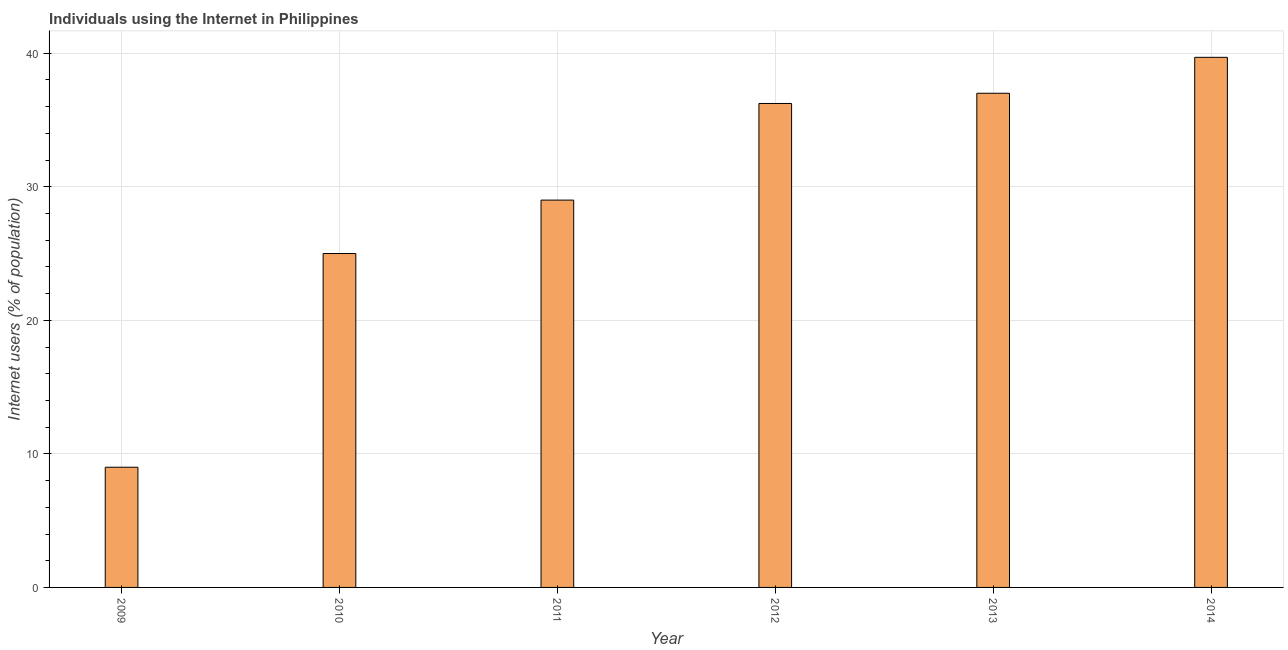Does the graph contain any zero values?
Keep it short and to the point. No. Does the graph contain grids?
Give a very brief answer. Yes. What is the title of the graph?
Provide a succinct answer. Individuals using the Internet in Philippines. What is the label or title of the X-axis?
Provide a succinct answer. Year. What is the label or title of the Y-axis?
Keep it short and to the point. Internet users (% of population). Across all years, what is the maximum number of internet users?
Offer a very short reply. 39.69. Across all years, what is the minimum number of internet users?
Make the answer very short. 9. In which year was the number of internet users maximum?
Your answer should be compact. 2014. In which year was the number of internet users minimum?
Your answer should be compact. 2009. What is the sum of the number of internet users?
Your response must be concise. 175.93. What is the difference between the number of internet users in 2010 and 2011?
Make the answer very short. -4. What is the average number of internet users per year?
Keep it short and to the point. 29.32. What is the median number of internet users?
Your answer should be compact. 32.62. In how many years, is the number of internet users greater than 24 %?
Keep it short and to the point. 5. What is the ratio of the number of internet users in 2011 to that in 2014?
Your answer should be compact. 0.73. What is the difference between the highest and the second highest number of internet users?
Offer a very short reply. 2.69. What is the difference between the highest and the lowest number of internet users?
Your answer should be compact. 30.69. Are all the bars in the graph horizontal?
Make the answer very short. No. Are the values on the major ticks of Y-axis written in scientific E-notation?
Keep it short and to the point. No. What is the Internet users (% of population) in 2009?
Your response must be concise. 9. What is the Internet users (% of population) in 2012?
Your answer should be very brief. 36.24. What is the Internet users (% of population) of 2014?
Offer a very short reply. 39.69. What is the difference between the Internet users (% of population) in 2009 and 2010?
Provide a succinct answer. -16. What is the difference between the Internet users (% of population) in 2009 and 2011?
Provide a succinct answer. -20. What is the difference between the Internet users (% of population) in 2009 and 2012?
Give a very brief answer. -27.24. What is the difference between the Internet users (% of population) in 2009 and 2013?
Keep it short and to the point. -28. What is the difference between the Internet users (% of population) in 2009 and 2014?
Your answer should be compact. -30.69. What is the difference between the Internet users (% of population) in 2010 and 2012?
Your answer should be very brief. -11.24. What is the difference between the Internet users (% of population) in 2010 and 2013?
Your response must be concise. -12. What is the difference between the Internet users (% of population) in 2010 and 2014?
Provide a short and direct response. -14.69. What is the difference between the Internet users (% of population) in 2011 and 2012?
Give a very brief answer. -7.24. What is the difference between the Internet users (% of population) in 2011 and 2013?
Ensure brevity in your answer.  -8. What is the difference between the Internet users (% of population) in 2011 and 2014?
Offer a very short reply. -10.69. What is the difference between the Internet users (% of population) in 2012 and 2013?
Provide a short and direct response. -0.76. What is the difference between the Internet users (% of population) in 2012 and 2014?
Your answer should be very brief. -3.45. What is the difference between the Internet users (% of population) in 2013 and 2014?
Ensure brevity in your answer.  -2.69. What is the ratio of the Internet users (% of population) in 2009 to that in 2010?
Make the answer very short. 0.36. What is the ratio of the Internet users (% of population) in 2009 to that in 2011?
Your response must be concise. 0.31. What is the ratio of the Internet users (% of population) in 2009 to that in 2012?
Ensure brevity in your answer.  0.25. What is the ratio of the Internet users (% of population) in 2009 to that in 2013?
Your response must be concise. 0.24. What is the ratio of the Internet users (% of population) in 2009 to that in 2014?
Keep it short and to the point. 0.23. What is the ratio of the Internet users (% of population) in 2010 to that in 2011?
Provide a short and direct response. 0.86. What is the ratio of the Internet users (% of population) in 2010 to that in 2012?
Keep it short and to the point. 0.69. What is the ratio of the Internet users (% of population) in 2010 to that in 2013?
Your answer should be very brief. 0.68. What is the ratio of the Internet users (% of population) in 2010 to that in 2014?
Provide a succinct answer. 0.63. What is the ratio of the Internet users (% of population) in 2011 to that in 2012?
Keep it short and to the point. 0.8. What is the ratio of the Internet users (% of population) in 2011 to that in 2013?
Your answer should be compact. 0.78. What is the ratio of the Internet users (% of population) in 2011 to that in 2014?
Provide a short and direct response. 0.73. What is the ratio of the Internet users (% of population) in 2013 to that in 2014?
Offer a terse response. 0.93. 